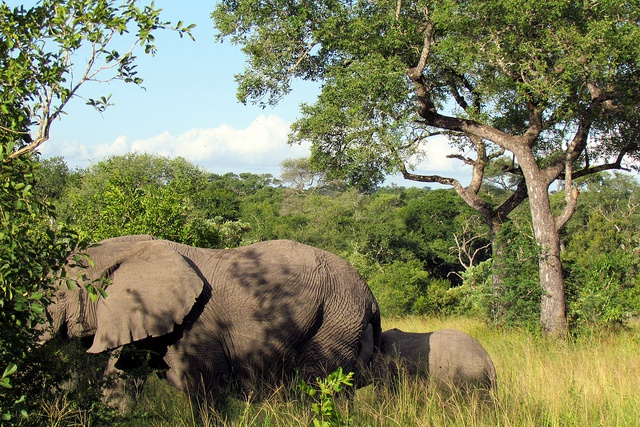Describe the objects in this image and their specific colors. I can see elephant in lightblue, black, tan, and gray tones and elephant in lightblue, tan, black, and gray tones in this image. 